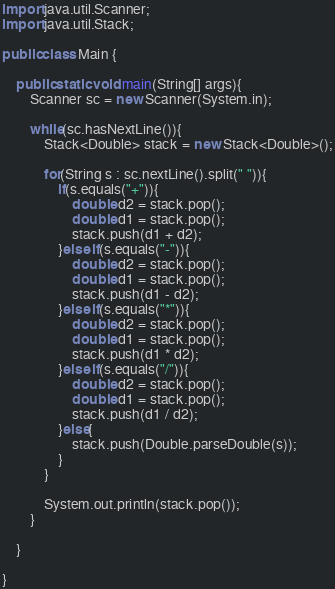<code> <loc_0><loc_0><loc_500><loc_500><_Java_>import java.util.Scanner;
import java.util.Stack;
  
public class Main {
      
    public static void main(String[] args){
        Scanner sc = new Scanner(System.in);
          
        while(sc.hasNextLine()){
            Stack<Double> stack = new Stack<Double>();
 
            for(String s : sc.nextLine().split(" ")){
                if(s.equals("+")){
                    double d2 = stack.pop();
                    double d1 = stack.pop();
                    stack.push(d1 + d2);
                }else if(s.equals("-")){
                    double d2 = stack.pop();
                    double d1 = stack.pop();
                    stack.push(d1 - d2);
                }else if(s.equals("*")){
                    double d2 = stack.pop();
                    double d1 = stack.pop();
                    stack.push(d1 * d2);
                }else if(s.equals("/")){
                    double d2 = stack.pop();
                    double d1 = stack.pop();
                    stack.push(d1 / d2);
                }else{
                    stack.push(Double.parseDouble(s));
                }
            }
              
            System.out.println(stack.pop());
        }
          
    }
      
}</code> 